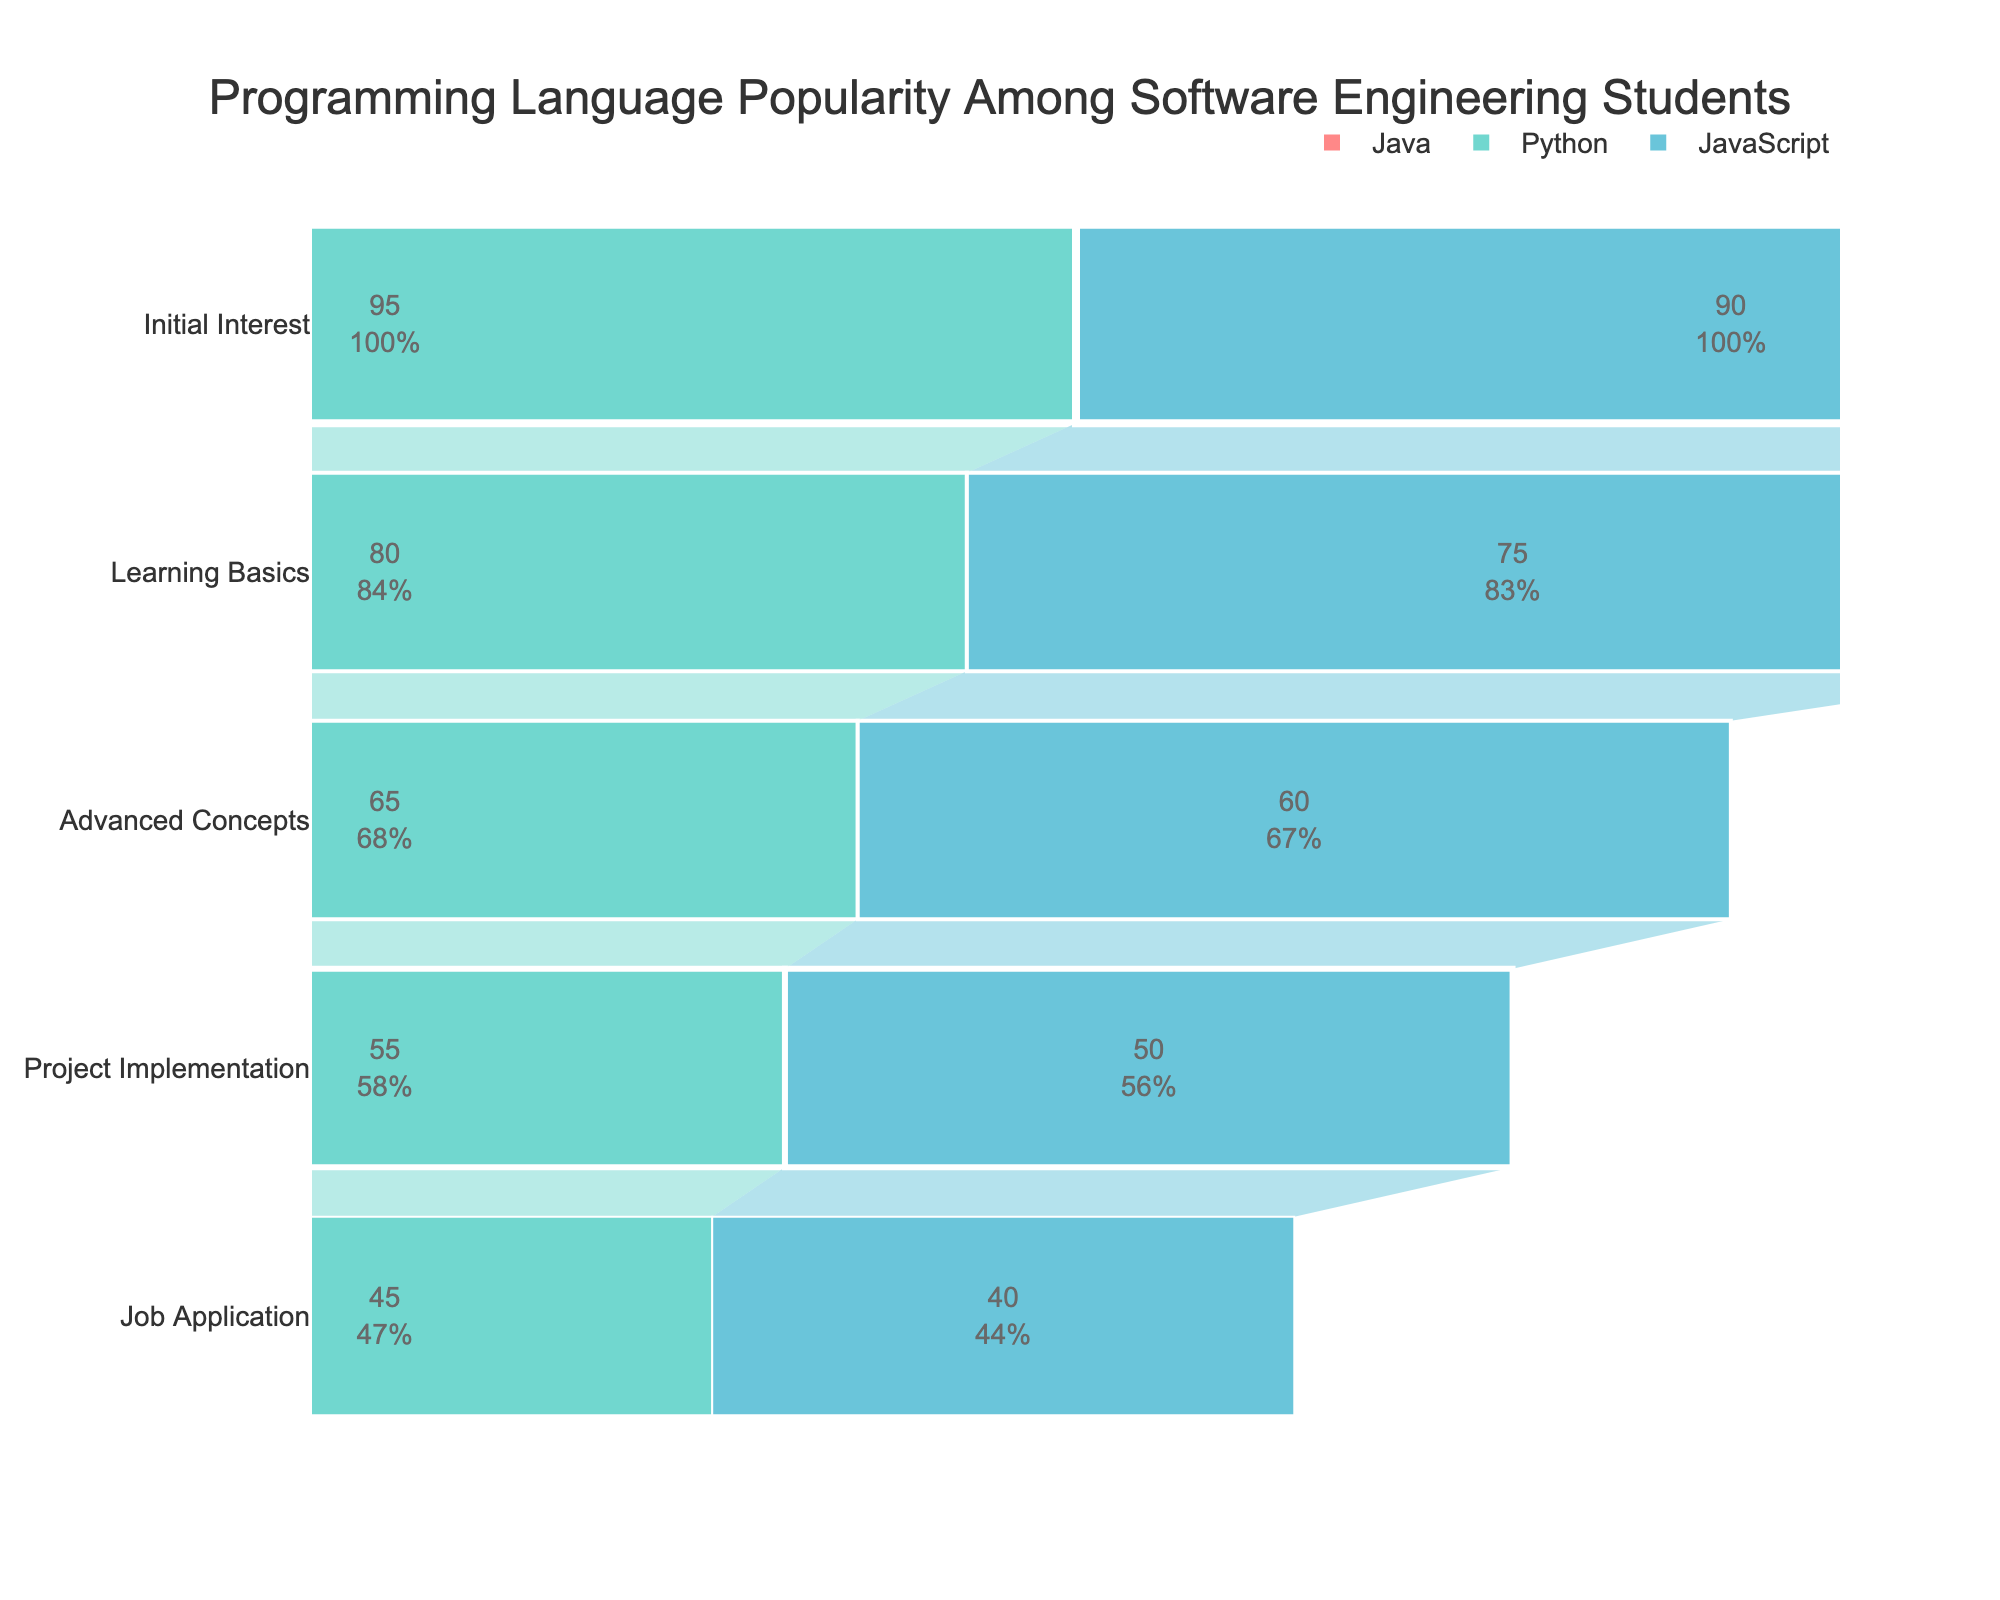what is the title of the figure? The title of the figure is displayed at the top of the chart.
Answer: Programming Language Popularity Among Software Engineering Students What percentage of students continue from learning basics to advanced concepts for Java? The figure shows that 85% of students are learning basics, and 70% proceed to advanced concepts. Calculate the proportion: (70/85) * 100 = 82.35%
Answer: 82.35% Which programming language has the lowest drop-off rate from initial interest to learning basics? Compare the percentage drop from initial interest to learning basics for each language: Java (100% to 85% = 15%), Python (95% to 80% = 15%), JavaScript (90% to 75% = 15%). They all have the same drop-off rate.
Answer: Java, Python, JavaScript At which stage does JavaScript lose the most students? Check the percentage drop at each stage for JavaScript and find the largest difference. From learning basics to advanced concepts, the drop is 75% to 60% which is 15%.
Answer: Learning Basics to Advanced Concepts Describe the trend for Java from project implementation to job application stages. From project implementation (60%) to job application (50%), Java shows a 10% decrease. This indicates a drop-off as students transition to the job application stage.
Answer: Decreasing by 10% How does Python compare to Java in the project implementation stage? Compare the percentages at the project implementation stage: Java has 60%, and Python has 55%. Python has a lower percentage.
Answer: Python is 5% lower Which language retains the highest percentage of students at the advanced concepts stage? Compare the percentages for advanced concepts: Java (70%), Python (65%), JavaScript (60%). Java retains the highest percentage.
Answer: Java If a student is interested in basic learning of JavaScript, how likely are they to start learning advanced concepts? The figure shows that 75% of students learn basics, and 60% learn advanced concepts for JavaScript. Calculate the proportion: (60/75) * 100 = 80%
Answer: 80% What is the percentage difference between Java and Python at the job application stage? Subtract the percentage of Python from Java at the job application stage: 50% - 45% = 5%. Java has a 5% higher percentage than Python.
Answer: 5% 